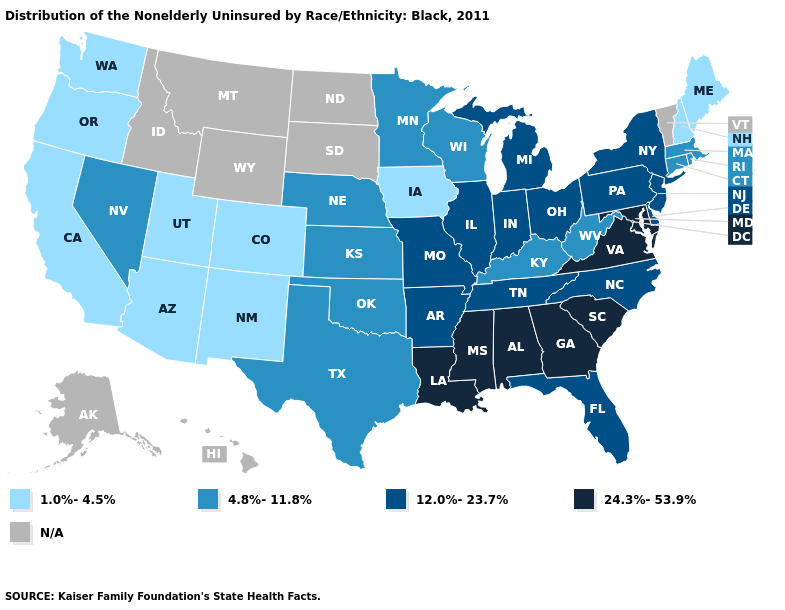Does the first symbol in the legend represent the smallest category?
Answer briefly. Yes. What is the value of Vermont?
Give a very brief answer. N/A. Name the states that have a value in the range 4.8%-11.8%?
Concise answer only. Connecticut, Kansas, Kentucky, Massachusetts, Minnesota, Nebraska, Nevada, Oklahoma, Rhode Island, Texas, West Virginia, Wisconsin. Among the states that border Maryland , does Virginia have the highest value?
Concise answer only. Yes. Does the map have missing data?
Answer briefly. Yes. Does Maryland have the highest value in the USA?
Keep it brief. Yes. Does the first symbol in the legend represent the smallest category?
Short answer required. Yes. Name the states that have a value in the range 24.3%-53.9%?
Write a very short answer. Alabama, Georgia, Louisiana, Maryland, Mississippi, South Carolina, Virginia. What is the highest value in the West ?
Answer briefly. 4.8%-11.8%. What is the value of Utah?
Short answer required. 1.0%-4.5%. What is the value of Utah?
Write a very short answer. 1.0%-4.5%. What is the highest value in the USA?
Quick response, please. 24.3%-53.9%. Does Iowa have the lowest value in the MidWest?
Be succinct. Yes. How many symbols are there in the legend?
Concise answer only. 5. 